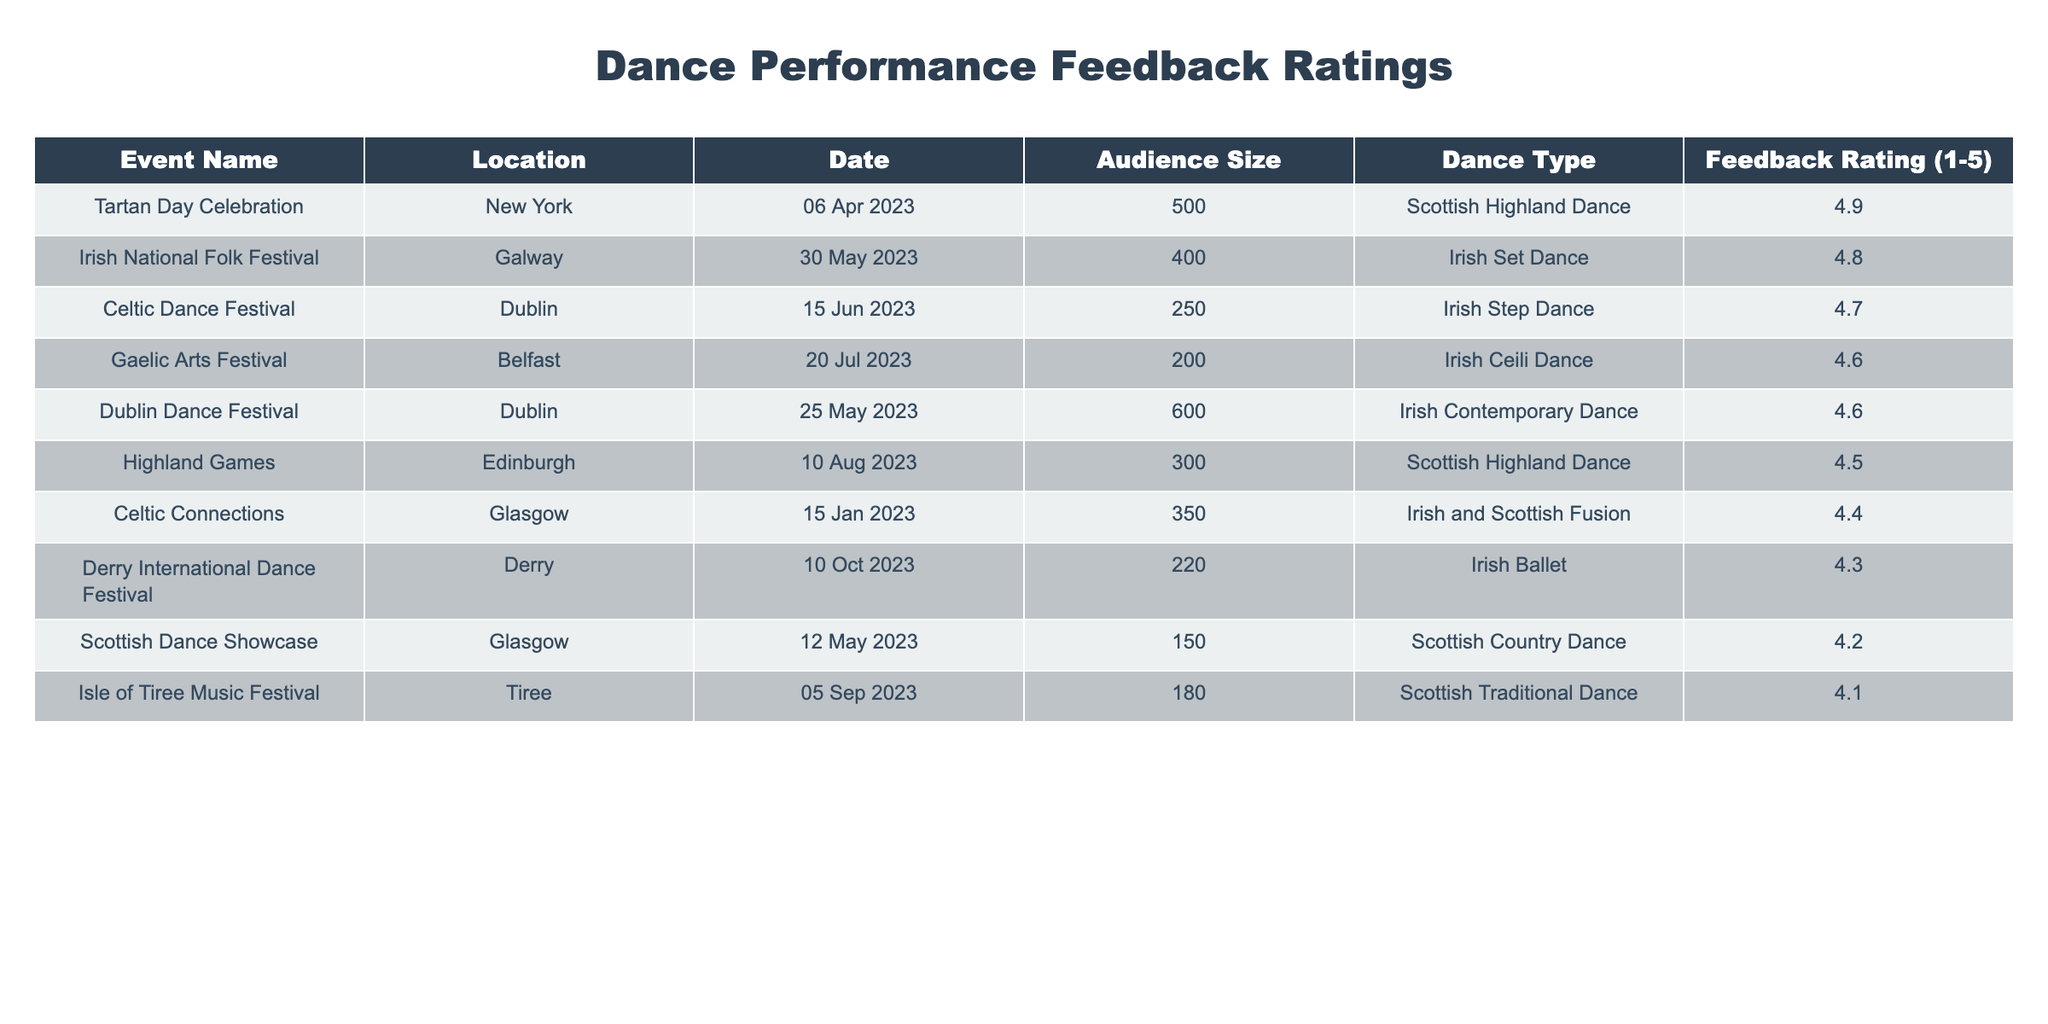What is the highest feedback rating among the performances? The highest feedback rating in the table is found in the "Irish National Folk Festival," which has a rating of 4.8.
Answer: 4.8 Which event had the lowest audience size? By examining the audience sizes in the table, the "Scottish Dance Showcase" had the lowest audience size at 150 attendees.
Answer: 150 What is the average feedback rating of the Irish dance performances? The Irish dance performances are "Irish Step Dance," "Irish Ceili Dance," "Irish Set Dance," "Irish Contemporary Dance," and "Irish Ballet," with feedback ratings of 4.7, 4.6, 4.8, 4.6, and 4.3 respectively. Adding these ratings gives 4.7 + 4.6 + 4.8 + 4.6 + 4.3 = 24. Overall there are 5 performances, 24/5 = 4.8 is the average rating.
Answer: 4.8 Was there any event that had a feedback rating of 4.9? Checking the feedback ratings in the table, the "Tartan Day Celebration" event does indeed have a feedback rating of 4.9.
Answer: Yes How many events had a feedback rating below 4.5? To find the number of events with a rating below 4.5, we can examine the ratings: "Scottish Country Dance" (4.2), "Scottish Traditional Dance" (4.1). There are 2 events below 4.5.
Answer: 2 Which dance type had the least favorable feedback rating on average? The "Scottish Traditional Dance" and "Scottish Country Dance" have lower feedback ratings compared to others. Using the available ratings, the average for Scottish dance types is (4.5 + 4.2 + 4.1) = 12.8 divided by 3 equals about 4.27. This indicates they have the least favorable average feedback.
Answer: Scottish Traditional Dance What total audience size attended the events with a feedback rating higher than 4.5? We can list the events with ratings higher than 4.5: "Celtic Dance Festival" (250), "Irish National Folk Festival" (400), "Tartan Day Celebration" (500), "Dublin Dance Festival" (600), "Gaelic Arts Festival" (200), and "Celtic Connections" (350). Summing gives 250 + 400 + 500 + 600 + 200 + 350 = 2300.
Answer: 2300 How many events took place in Dublin? By reviewing the locations of the events in the table, "Celtic Dance Festival" and "Dublin Dance Festival" are the two events that took place in Dublin.
Answer: 2 